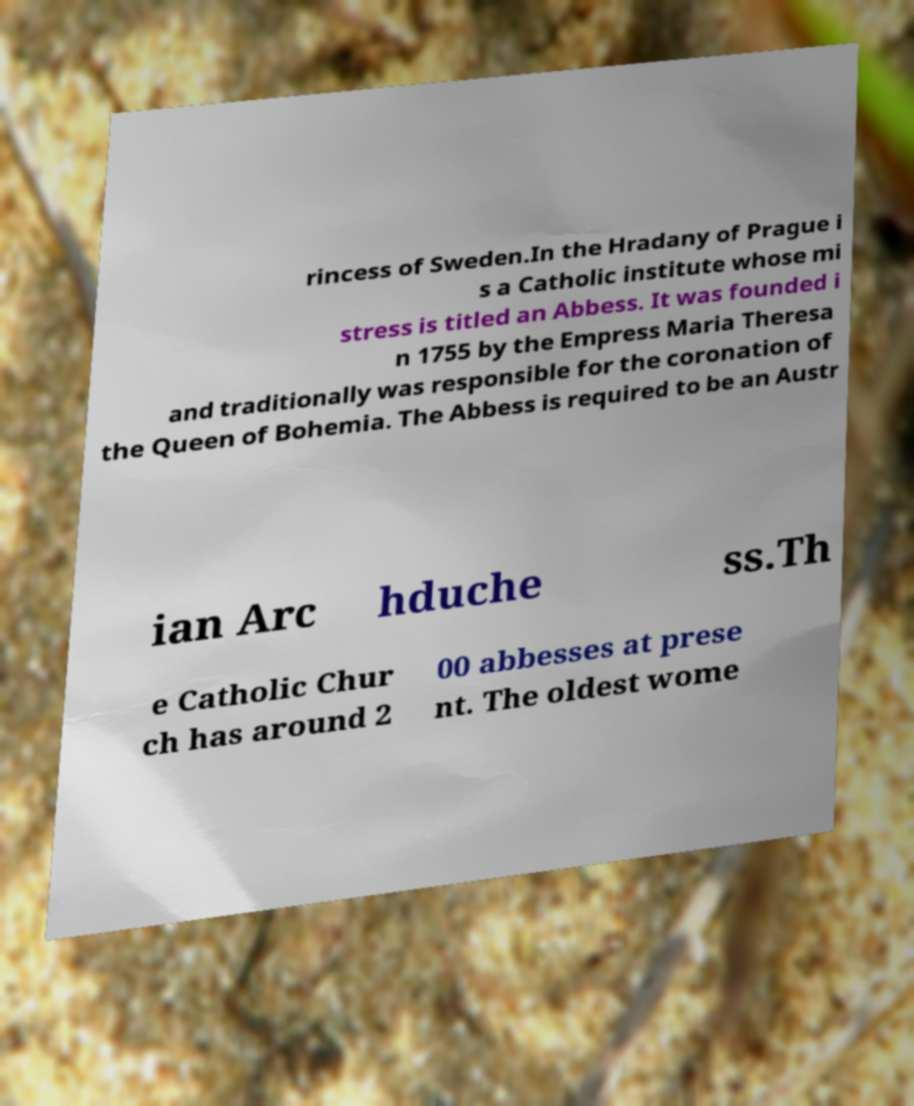I need the written content from this picture converted into text. Can you do that? rincess of Sweden.In the Hradany of Prague i s a Catholic institute whose mi stress is titled an Abbess. It was founded i n 1755 by the Empress Maria Theresa and traditionally was responsible for the coronation of the Queen of Bohemia. The Abbess is required to be an Austr ian Arc hduche ss.Th e Catholic Chur ch has around 2 00 abbesses at prese nt. The oldest wome 